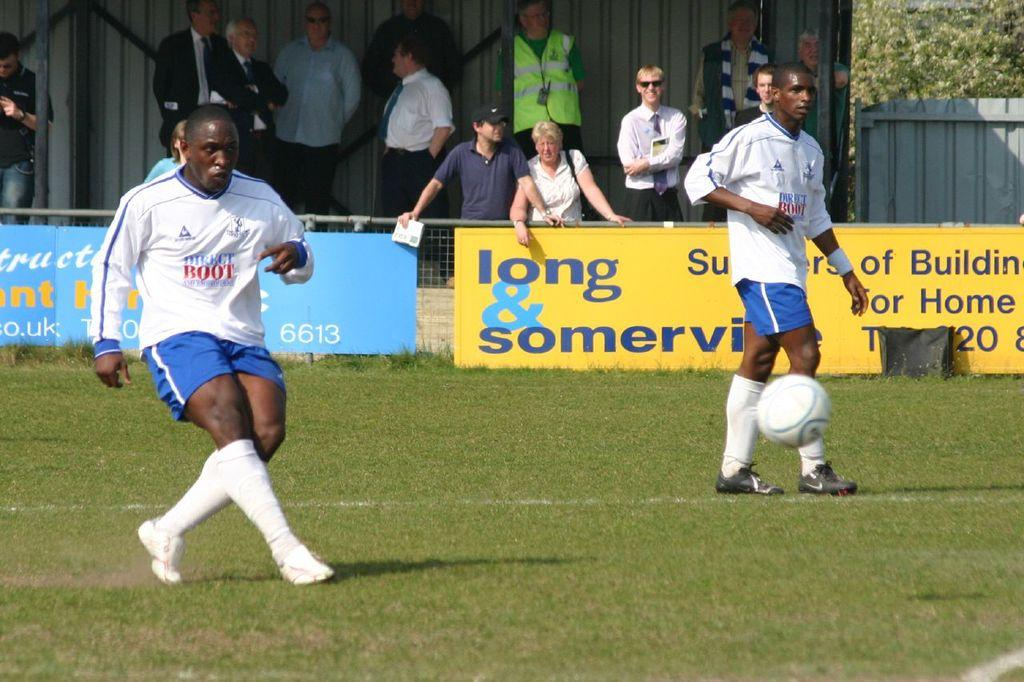Provide a one-sentence caption for the provided image. Football players are on a field in front of a yellow banner reading long & somerville. 